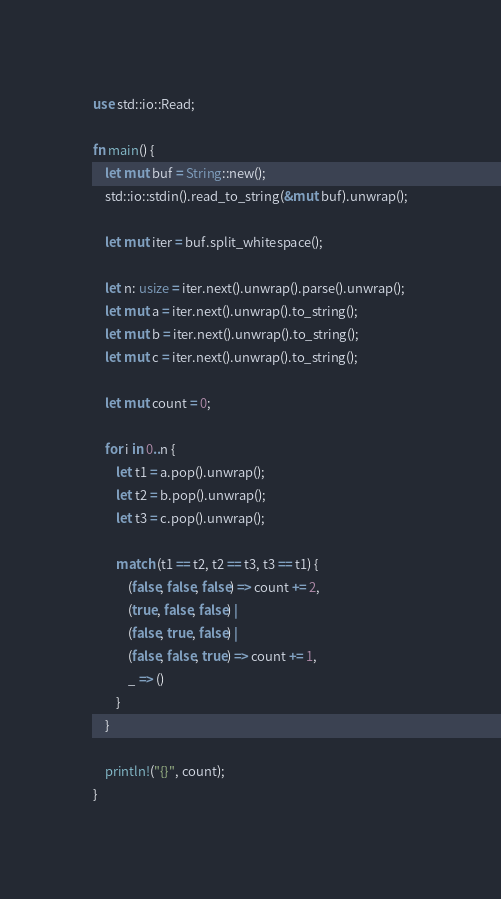<code> <loc_0><loc_0><loc_500><loc_500><_Rust_>use std::io::Read;

fn main() {
    let mut buf = String::new();
    std::io::stdin().read_to_string(&mut buf).unwrap();
    
    let mut iter = buf.split_whitespace();
    
    let n: usize = iter.next().unwrap().parse().unwrap();
    let mut a = iter.next().unwrap().to_string();
    let mut b = iter.next().unwrap().to_string();
    let mut c = iter.next().unwrap().to_string();
    
    let mut count = 0;
    
    for i in 0..n {
        let t1 = a.pop().unwrap();
        let t2 = b.pop().unwrap();
        let t3 = c.pop().unwrap();
        
        match (t1 == t2, t2 == t3, t3 == t1) {
            (false, false, false) => count += 2,
            (true, false, false) |
            (false, true, false) |
            (false, false, true) => count += 1,
            _ => ()
        }
    }
    
    println!("{}", count);
}</code> 